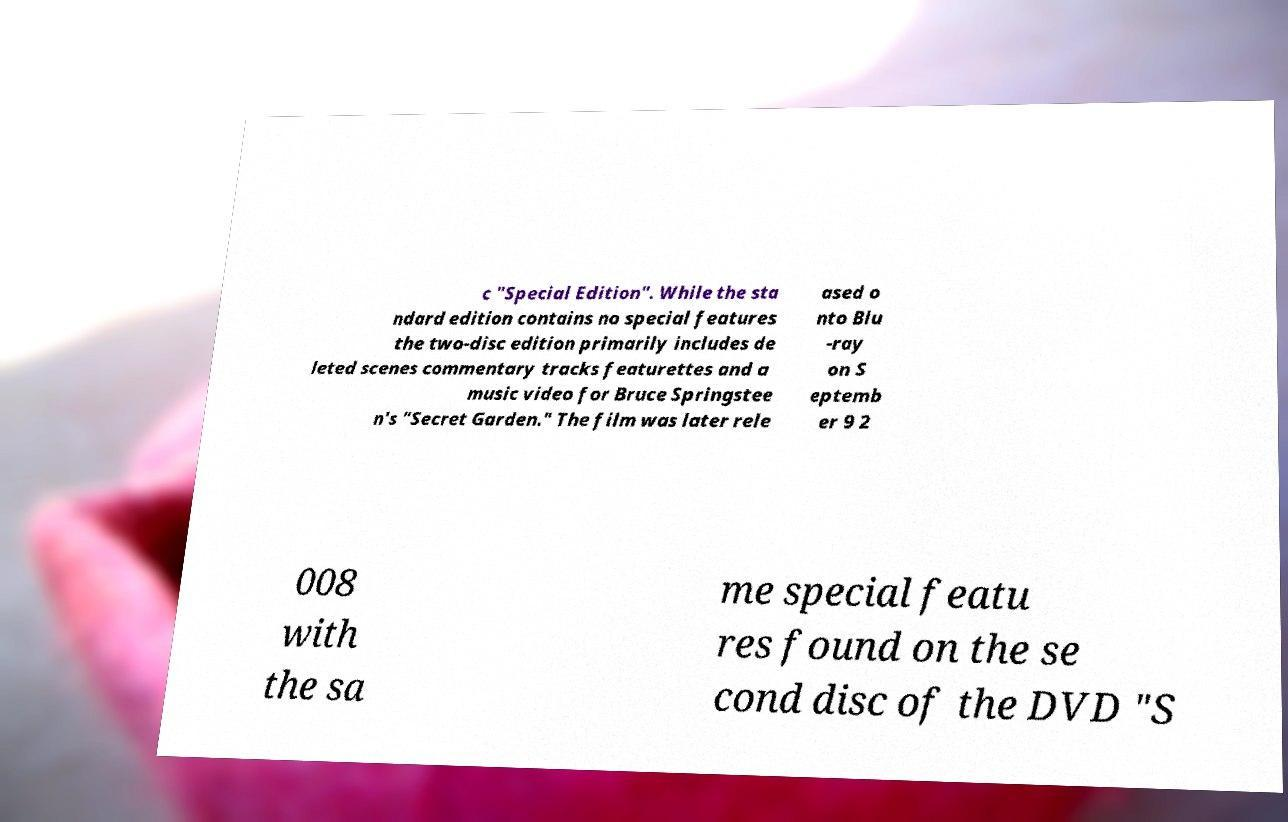There's text embedded in this image that I need extracted. Can you transcribe it verbatim? c "Special Edition". While the sta ndard edition contains no special features the two-disc edition primarily includes de leted scenes commentary tracks featurettes and a music video for Bruce Springstee n's "Secret Garden." The film was later rele ased o nto Blu -ray on S eptemb er 9 2 008 with the sa me special featu res found on the se cond disc of the DVD "S 